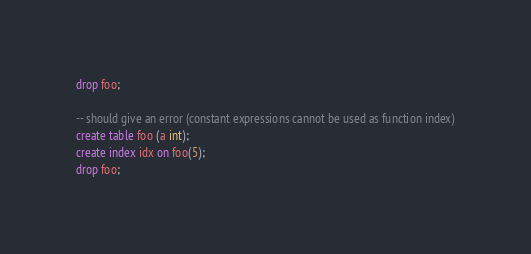Convert code to text. <code><loc_0><loc_0><loc_500><loc_500><_SQL_>
drop foo;

-- should give an error (constant expressions cannot be used as function index)
create table foo (a int);
create index idx on foo(5);
drop foo;
</code> 